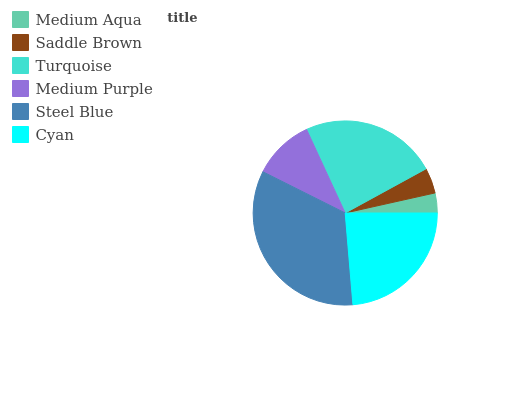Is Medium Aqua the minimum?
Answer yes or no. Yes. Is Steel Blue the maximum?
Answer yes or no. Yes. Is Saddle Brown the minimum?
Answer yes or no. No. Is Saddle Brown the maximum?
Answer yes or no. No. Is Saddle Brown greater than Medium Aqua?
Answer yes or no. Yes. Is Medium Aqua less than Saddle Brown?
Answer yes or no. Yes. Is Medium Aqua greater than Saddle Brown?
Answer yes or no. No. Is Saddle Brown less than Medium Aqua?
Answer yes or no. No. Is Cyan the high median?
Answer yes or no. Yes. Is Medium Purple the low median?
Answer yes or no. Yes. Is Saddle Brown the high median?
Answer yes or no. No. Is Medium Aqua the low median?
Answer yes or no. No. 